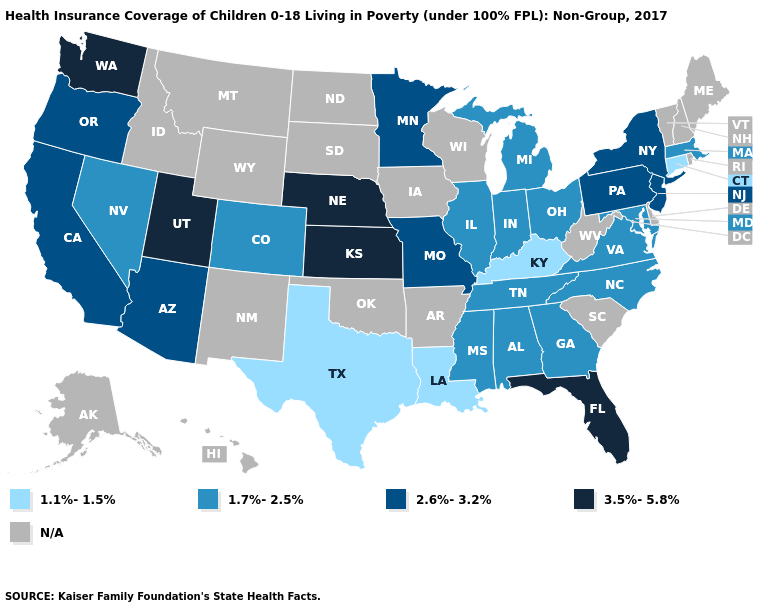Does New Jersey have the highest value in the USA?
Write a very short answer. No. Does the map have missing data?
Short answer required. Yes. Name the states that have a value in the range 3.5%-5.8%?
Keep it brief. Florida, Kansas, Nebraska, Utah, Washington. What is the value of Connecticut?
Give a very brief answer. 1.1%-1.5%. Does the first symbol in the legend represent the smallest category?
Keep it brief. Yes. What is the value of Nevada?
Answer briefly. 1.7%-2.5%. Does North Carolina have the lowest value in the USA?
Give a very brief answer. No. What is the value of Colorado?
Quick response, please. 1.7%-2.5%. Name the states that have a value in the range 3.5%-5.8%?
Concise answer only. Florida, Kansas, Nebraska, Utah, Washington. Does Oregon have the lowest value in the USA?
Short answer required. No. What is the lowest value in the USA?
Concise answer only. 1.1%-1.5%. Does New York have the highest value in the Northeast?
Concise answer only. Yes. Name the states that have a value in the range 2.6%-3.2%?
Write a very short answer. Arizona, California, Minnesota, Missouri, New Jersey, New York, Oregon, Pennsylvania. What is the value of Missouri?
Concise answer only. 2.6%-3.2%. 